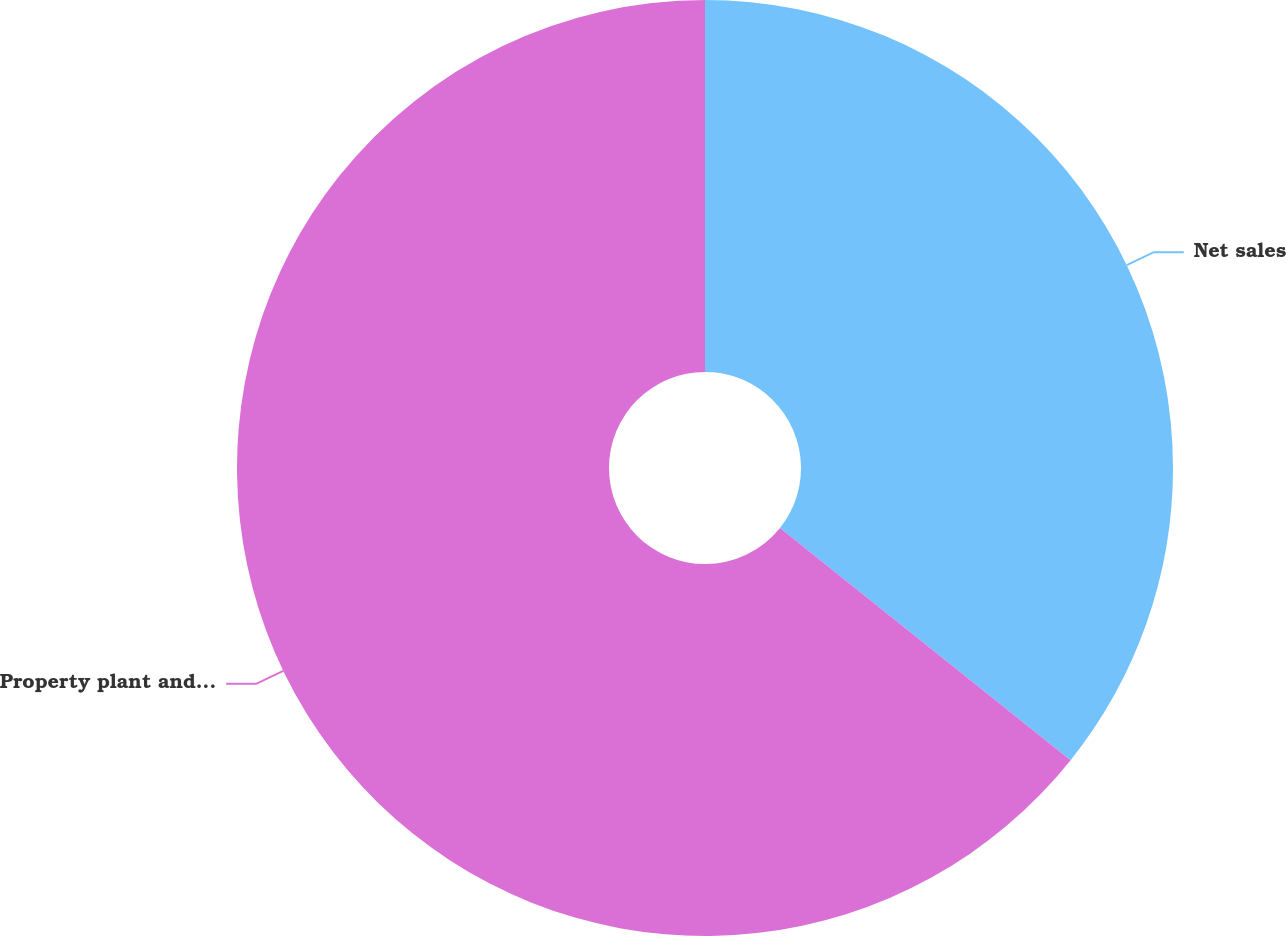Convert chart to OTSL. <chart><loc_0><loc_0><loc_500><loc_500><pie_chart><fcel>Net sales<fcel>Property plant and equipment<nl><fcel>35.73%<fcel>64.27%<nl></chart> 